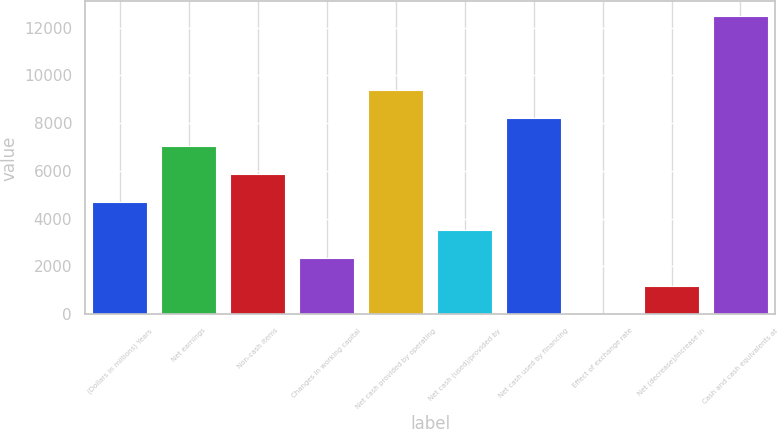Convert chart. <chart><loc_0><loc_0><loc_500><loc_500><bar_chart><fcel>(Dollars in millions) Years<fcel>Net earnings<fcel>Non-cash items<fcel>Changes in working capital<fcel>Net cash provided by operating<fcel>Net cash (used)/provided by<fcel>Net cash used by financing<fcel>Effect of exchange rate<fcel>Net (decrease)/increase in<fcel>Cash and cash equivalents at<nl><fcel>4710<fcel>7051<fcel>5880.5<fcel>2369<fcel>9392<fcel>3539.5<fcel>8221.5<fcel>28<fcel>1198.5<fcel>12472.5<nl></chart> 